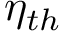Convert formula to latex. <formula><loc_0><loc_0><loc_500><loc_500>\eta _ { t h }</formula> 